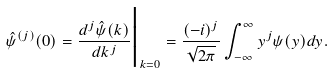<formula> <loc_0><loc_0><loc_500><loc_500>\hat { \psi } ^ { ( j ) } ( 0 ) = \frac { d ^ { j } \hat { \psi } ( k ) } { d k ^ { j } } \Big | _ { k = 0 } = \frac { ( - i ) ^ { j } } { \sqrt { 2 \pi } } \int _ { - \infty } ^ { \infty } y ^ { j } \psi ( y ) d y .</formula> 